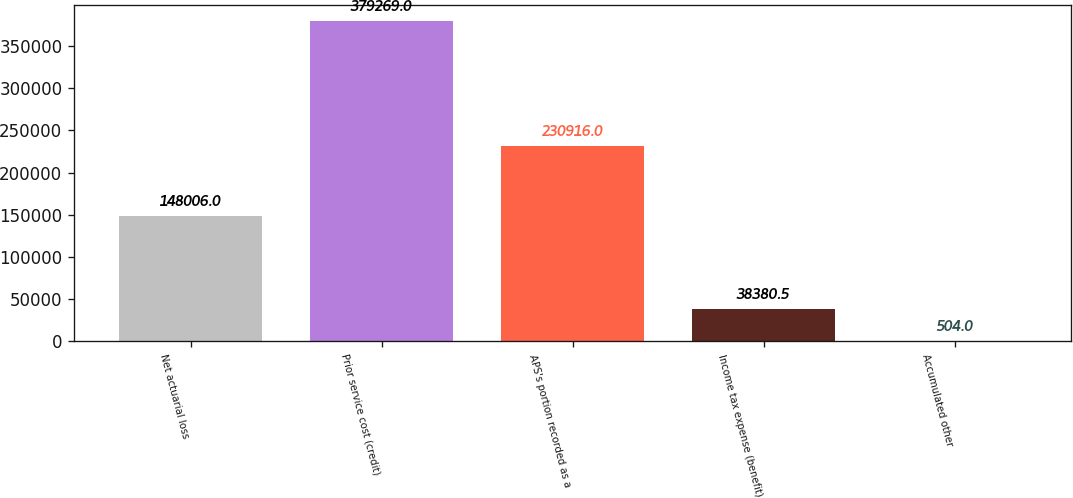Convert chart to OTSL. <chart><loc_0><loc_0><loc_500><loc_500><bar_chart><fcel>Net actuarial loss<fcel>Prior service cost (credit)<fcel>APS's portion recorded as a<fcel>Income tax expense (benefit)<fcel>Accumulated other<nl><fcel>148006<fcel>379269<fcel>230916<fcel>38380.5<fcel>504<nl></chart> 